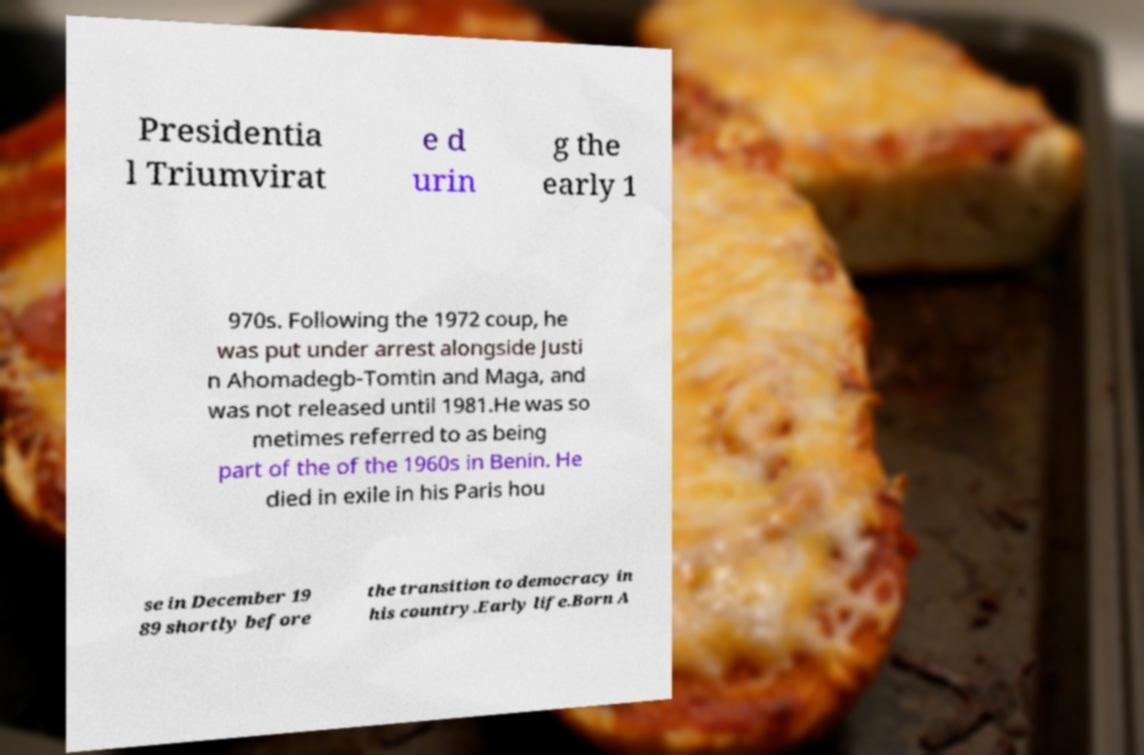I need the written content from this picture converted into text. Can you do that? Presidentia l Triumvirat e d urin g the early 1 970s. Following the 1972 coup, he was put under arrest alongside Justi n Ahomadegb-Tomtin and Maga, and was not released until 1981.He was so metimes referred to as being part of the of the 1960s in Benin. He died in exile in his Paris hou se in December 19 89 shortly before the transition to democracy in his country.Early life.Born A 